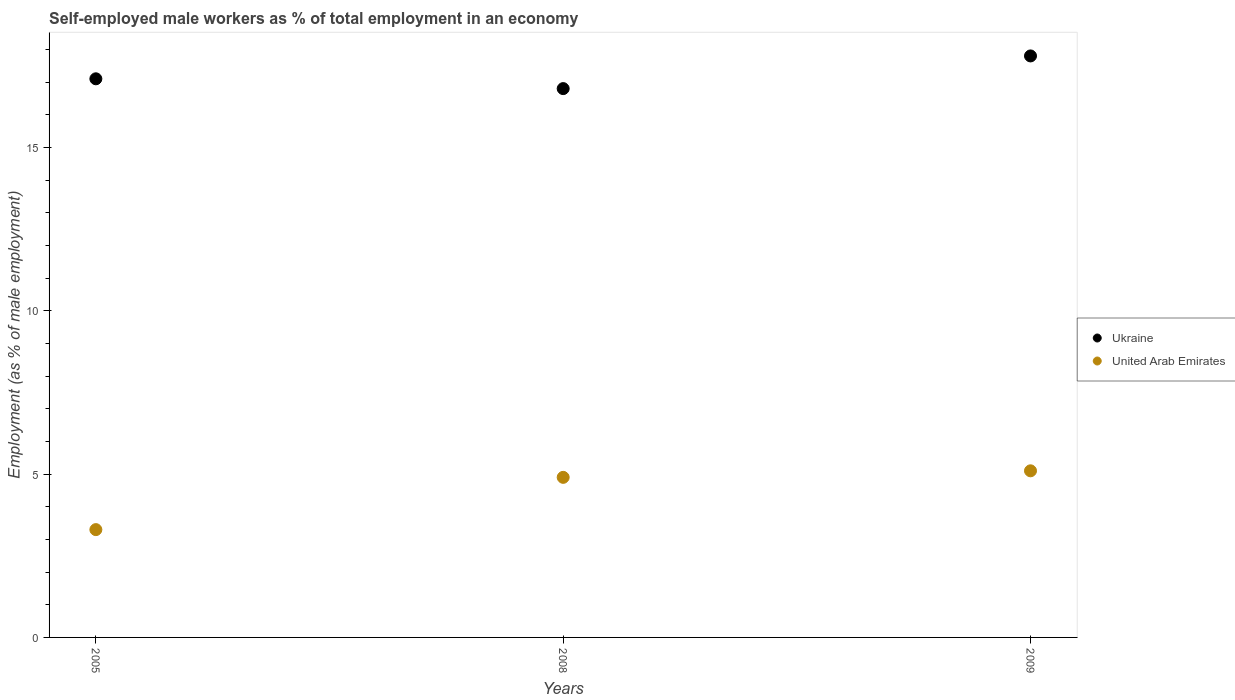How many different coloured dotlines are there?
Keep it short and to the point. 2. Is the number of dotlines equal to the number of legend labels?
Offer a very short reply. Yes. What is the percentage of self-employed male workers in Ukraine in 2009?
Your answer should be very brief. 17.8. Across all years, what is the maximum percentage of self-employed male workers in Ukraine?
Provide a succinct answer. 17.8. Across all years, what is the minimum percentage of self-employed male workers in Ukraine?
Offer a terse response. 16.8. What is the total percentage of self-employed male workers in United Arab Emirates in the graph?
Keep it short and to the point. 13.3. What is the difference between the percentage of self-employed male workers in United Arab Emirates in 2005 and that in 2009?
Make the answer very short. -1.8. What is the difference between the percentage of self-employed male workers in Ukraine in 2008 and the percentage of self-employed male workers in United Arab Emirates in 2009?
Offer a very short reply. 11.7. What is the average percentage of self-employed male workers in Ukraine per year?
Your answer should be compact. 17.23. In the year 2005, what is the difference between the percentage of self-employed male workers in Ukraine and percentage of self-employed male workers in United Arab Emirates?
Your answer should be compact. 13.8. In how many years, is the percentage of self-employed male workers in Ukraine greater than 13 %?
Make the answer very short. 3. What is the ratio of the percentage of self-employed male workers in Ukraine in 2005 to that in 2009?
Your answer should be very brief. 0.96. Is the difference between the percentage of self-employed male workers in Ukraine in 2005 and 2008 greater than the difference between the percentage of self-employed male workers in United Arab Emirates in 2005 and 2008?
Your answer should be compact. Yes. What is the difference between the highest and the second highest percentage of self-employed male workers in Ukraine?
Make the answer very short. 0.7. Is the sum of the percentage of self-employed male workers in Ukraine in 2005 and 2009 greater than the maximum percentage of self-employed male workers in United Arab Emirates across all years?
Provide a succinct answer. Yes. Is the percentage of self-employed male workers in United Arab Emirates strictly less than the percentage of self-employed male workers in Ukraine over the years?
Give a very brief answer. Yes. How many years are there in the graph?
Keep it short and to the point. 3. Does the graph contain any zero values?
Make the answer very short. No. Does the graph contain grids?
Keep it short and to the point. No. How many legend labels are there?
Your answer should be very brief. 2. What is the title of the graph?
Offer a terse response. Self-employed male workers as % of total employment in an economy. What is the label or title of the Y-axis?
Provide a short and direct response. Employment (as % of male employment). What is the Employment (as % of male employment) in Ukraine in 2005?
Offer a terse response. 17.1. What is the Employment (as % of male employment) of United Arab Emirates in 2005?
Your answer should be compact. 3.3. What is the Employment (as % of male employment) in Ukraine in 2008?
Ensure brevity in your answer.  16.8. What is the Employment (as % of male employment) of United Arab Emirates in 2008?
Offer a terse response. 4.9. What is the Employment (as % of male employment) in Ukraine in 2009?
Ensure brevity in your answer.  17.8. What is the Employment (as % of male employment) in United Arab Emirates in 2009?
Offer a very short reply. 5.1. Across all years, what is the maximum Employment (as % of male employment) of Ukraine?
Provide a short and direct response. 17.8. Across all years, what is the maximum Employment (as % of male employment) in United Arab Emirates?
Keep it short and to the point. 5.1. Across all years, what is the minimum Employment (as % of male employment) of Ukraine?
Offer a very short reply. 16.8. Across all years, what is the minimum Employment (as % of male employment) of United Arab Emirates?
Offer a terse response. 3.3. What is the total Employment (as % of male employment) in Ukraine in the graph?
Make the answer very short. 51.7. What is the difference between the Employment (as % of male employment) in Ukraine in 2008 and that in 2009?
Offer a very short reply. -1. What is the difference between the Employment (as % of male employment) in Ukraine in 2005 and the Employment (as % of male employment) in United Arab Emirates in 2008?
Your answer should be very brief. 12.2. What is the difference between the Employment (as % of male employment) in Ukraine in 2005 and the Employment (as % of male employment) in United Arab Emirates in 2009?
Provide a short and direct response. 12. What is the difference between the Employment (as % of male employment) in Ukraine in 2008 and the Employment (as % of male employment) in United Arab Emirates in 2009?
Ensure brevity in your answer.  11.7. What is the average Employment (as % of male employment) of Ukraine per year?
Make the answer very short. 17.23. What is the average Employment (as % of male employment) in United Arab Emirates per year?
Make the answer very short. 4.43. In the year 2005, what is the difference between the Employment (as % of male employment) of Ukraine and Employment (as % of male employment) of United Arab Emirates?
Offer a very short reply. 13.8. In the year 2008, what is the difference between the Employment (as % of male employment) in Ukraine and Employment (as % of male employment) in United Arab Emirates?
Give a very brief answer. 11.9. In the year 2009, what is the difference between the Employment (as % of male employment) in Ukraine and Employment (as % of male employment) in United Arab Emirates?
Offer a terse response. 12.7. What is the ratio of the Employment (as % of male employment) of Ukraine in 2005 to that in 2008?
Provide a short and direct response. 1.02. What is the ratio of the Employment (as % of male employment) of United Arab Emirates in 2005 to that in 2008?
Keep it short and to the point. 0.67. What is the ratio of the Employment (as % of male employment) in Ukraine in 2005 to that in 2009?
Offer a terse response. 0.96. What is the ratio of the Employment (as % of male employment) of United Arab Emirates in 2005 to that in 2009?
Offer a very short reply. 0.65. What is the ratio of the Employment (as % of male employment) of Ukraine in 2008 to that in 2009?
Keep it short and to the point. 0.94. What is the ratio of the Employment (as % of male employment) of United Arab Emirates in 2008 to that in 2009?
Provide a short and direct response. 0.96. What is the difference between the highest and the second highest Employment (as % of male employment) in Ukraine?
Your answer should be very brief. 0.7. What is the difference between the highest and the lowest Employment (as % of male employment) in Ukraine?
Offer a terse response. 1. What is the difference between the highest and the lowest Employment (as % of male employment) of United Arab Emirates?
Offer a very short reply. 1.8. 